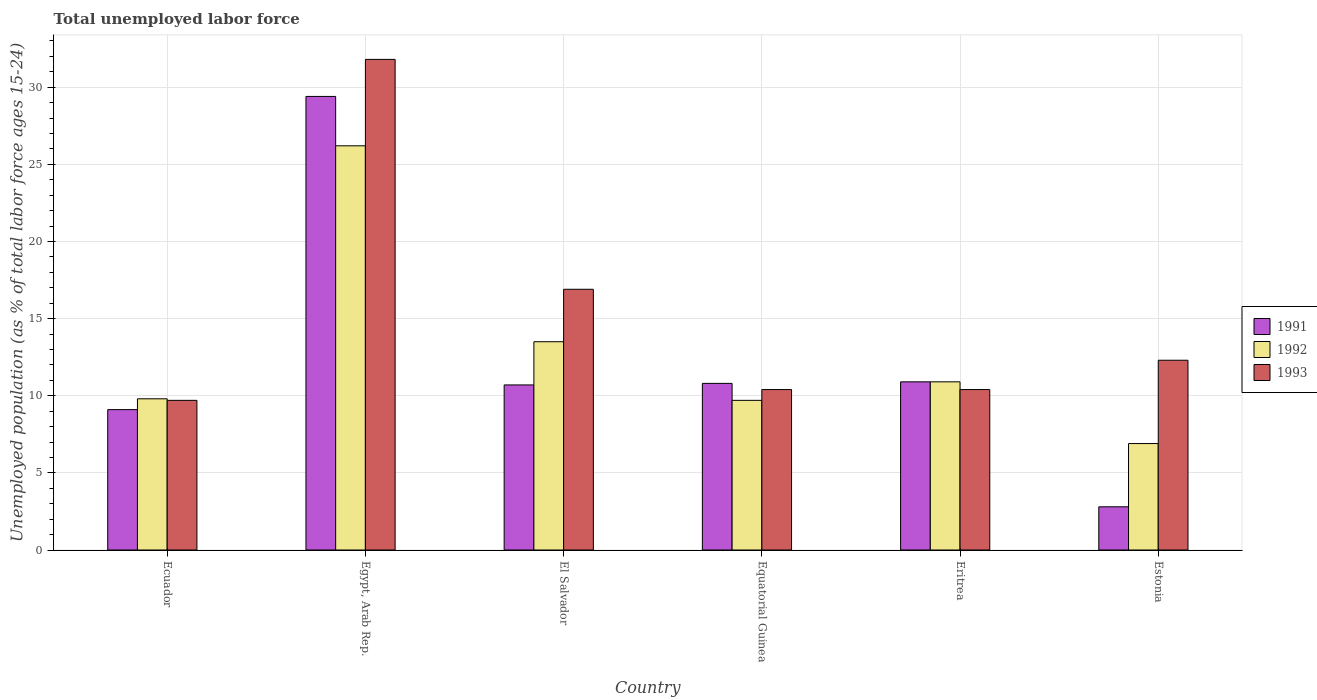How many different coloured bars are there?
Your response must be concise. 3. How many groups of bars are there?
Keep it short and to the point. 6. Are the number of bars per tick equal to the number of legend labels?
Your response must be concise. Yes. Are the number of bars on each tick of the X-axis equal?
Make the answer very short. Yes. How many bars are there on the 4th tick from the left?
Provide a short and direct response. 3. What is the label of the 4th group of bars from the left?
Your answer should be very brief. Equatorial Guinea. In how many cases, is the number of bars for a given country not equal to the number of legend labels?
Give a very brief answer. 0. What is the percentage of unemployed population in in 1992 in Equatorial Guinea?
Keep it short and to the point. 9.7. Across all countries, what is the maximum percentage of unemployed population in in 1992?
Give a very brief answer. 26.2. Across all countries, what is the minimum percentage of unemployed population in in 1991?
Your answer should be compact. 2.8. In which country was the percentage of unemployed population in in 1993 maximum?
Make the answer very short. Egypt, Arab Rep. In which country was the percentage of unemployed population in in 1993 minimum?
Keep it short and to the point. Ecuador. What is the total percentage of unemployed population in in 1991 in the graph?
Make the answer very short. 73.7. What is the difference between the percentage of unemployed population in in 1992 in Equatorial Guinea and that in Estonia?
Provide a succinct answer. 2.8. What is the difference between the percentage of unemployed population in in 1992 in Estonia and the percentage of unemployed population in in 1993 in Ecuador?
Your response must be concise. -2.8. What is the average percentage of unemployed population in in 1991 per country?
Give a very brief answer. 12.28. What is the difference between the percentage of unemployed population in of/in 1992 and percentage of unemployed population in of/in 1991 in Equatorial Guinea?
Offer a very short reply. -1.1. In how many countries, is the percentage of unemployed population in in 1992 greater than 3 %?
Your response must be concise. 6. What is the ratio of the percentage of unemployed population in in 1991 in Equatorial Guinea to that in Estonia?
Your response must be concise. 3.86. Is the percentage of unemployed population in in 1992 in Ecuador less than that in El Salvador?
Ensure brevity in your answer.  Yes. Is the difference between the percentage of unemployed population in in 1992 in Ecuador and Estonia greater than the difference between the percentage of unemployed population in in 1991 in Ecuador and Estonia?
Give a very brief answer. No. What is the difference between the highest and the second highest percentage of unemployed population in in 1993?
Your answer should be compact. 4.6. What is the difference between the highest and the lowest percentage of unemployed population in in 1993?
Give a very brief answer. 22.1. In how many countries, is the percentage of unemployed population in in 1993 greater than the average percentage of unemployed population in in 1993 taken over all countries?
Your answer should be compact. 2. Is the sum of the percentage of unemployed population in in 1992 in Ecuador and Eritrea greater than the maximum percentage of unemployed population in in 1993 across all countries?
Your answer should be compact. No. What does the 2nd bar from the right in Eritrea represents?
Offer a terse response. 1992. Is it the case that in every country, the sum of the percentage of unemployed population in in 1993 and percentage of unemployed population in in 1992 is greater than the percentage of unemployed population in in 1991?
Provide a succinct answer. Yes. Are all the bars in the graph horizontal?
Give a very brief answer. No. How many countries are there in the graph?
Provide a succinct answer. 6. What is the difference between two consecutive major ticks on the Y-axis?
Keep it short and to the point. 5. How many legend labels are there?
Your answer should be compact. 3. How are the legend labels stacked?
Your answer should be compact. Vertical. What is the title of the graph?
Keep it short and to the point. Total unemployed labor force. Does "1996" appear as one of the legend labels in the graph?
Your answer should be very brief. No. What is the label or title of the Y-axis?
Ensure brevity in your answer.  Unemployed population (as % of total labor force ages 15-24). What is the Unemployed population (as % of total labor force ages 15-24) of 1991 in Ecuador?
Offer a terse response. 9.1. What is the Unemployed population (as % of total labor force ages 15-24) in 1992 in Ecuador?
Offer a terse response. 9.8. What is the Unemployed population (as % of total labor force ages 15-24) in 1993 in Ecuador?
Your response must be concise. 9.7. What is the Unemployed population (as % of total labor force ages 15-24) in 1991 in Egypt, Arab Rep.?
Provide a short and direct response. 29.4. What is the Unemployed population (as % of total labor force ages 15-24) in 1992 in Egypt, Arab Rep.?
Provide a short and direct response. 26.2. What is the Unemployed population (as % of total labor force ages 15-24) in 1993 in Egypt, Arab Rep.?
Offer a terse response. 31.8. What is the Unemployed population (as % of total labor force ages 15-24) of 1991 in El Salvador?
Ensure brevity in your answer.  10.7. What is the Unemployed population (as % of total labor force ages 15-24) in 1993 in El Salvador?
Keep it short and to the point. 16.9. What is the Unemployed population (as % of total labor force ages 15-24) of 1991 in Equatorial Guinea?
Provide a short and direct response. 10.8. What is the Unemployed population (as % of total labor force ages 15-24) in 1992 in Equatorial Guinea?
Your response must be concise. 9.7. What is the Unemployed population (as % of total labor force ages 15-24) in 1993 in Equatorial Guinea?
Offer a very short reply. 10.4. What is the Unemployed population (as % of total labor force ages 15-24) of 1991 in Eritrea?
Your response must be concise. 10.9. What is the Unemployed population (as % of total labor force ages 15-24) in 1992 in Eritrea?
Keep it short and to the point. 10.9. What is the Unemployed population (as % of total labor force ages 15-24) of 1993 in Eritrea?
Provide a short and direct response. 10.4. What is the Unemployed population (as % of total labor force ages 15-24) in 1991 in Estonia?
Ensure brevity in your answer.  2.8. What is the Unemployed population (as % of total labor force ages 15-24) in 1992 in Estonia?
Make the answer very short. 6.9. What is the Unemployed population (as % of total labor force ages 15-24) in 1993 in Estonia?
Offer a very short reply. 12.3. Across all countries, what is the maximum Unemployed population (as % of total labor force ages 15-24) of 1991?
Your answer should be very brief. 29.4. Across all countries, what is the maximum Unemployed population (as % of total labor force ages 15-24) in 1992?
Give a very brief answer. 26.2. Across all countries, what is the maximum Unemployed population (as % of total labor force ages 15-24) in 1993?
Keep it short and to the point. 31.8. Across all countries, what is the minimum Unemployed population (as % of total labor force ages 15-24) in 1991?
Offer a very short reply. 2.8. Across all countries, what is the minimum Unemployed population (as % of total labor force ages 15-24) in 1992?
Give a very brief answer. 6.9. Across all countries, what is the minimum Unemployed population (as % of total labor force ages 15-24) of 1993?
Your answer should be compact. 9.7. What is the total Unemployed population (as % of total labor force ages 15-24) in 1991 in the graph?
Make the answer very short. 73.7. What is the total Unemployed population (as % of total labor force ages 15-24) in 1993 in the graph?
Provide a short and direct response. 91.5. What is the difference between the Unemployed population (as % of total labor force ages 15-24) of 1991 in Ecuador and that in Egypt, Arab Rep.?
Your answer should be compact. -20.3. What is the difference between the Unemployed population (as % of total labor force ages 15-24) of 1992 in Ecuador and that in Egypt, Arab Rep.?
Your response must be concise. -16.4. What is the difference between the Unemployed population (as % of total labor force ages 15-24) in 1993 in Ecuador and that in Egypt, Arab Rep.?
Keep it short and to the point. -22.1. What is the difference between the Unemployed population (as % of total labor force ages 15-24) of 1991 in Ecuador and that in El Salvador?
Offer a terse response. -1.6. What is the difference between the Unemployed population (as % of total labor force ages 15-24) of 1993 in Ecuador and that in El Salvador?
Your answer should be compact. -7.2. What is the difference between the Unemployed population (as % of total labor force ages 15-24) of 1991 in Ecuador and that in Equatorial Guinea?
Give a very brief answer. -1.7. What is the difference between the Unemployed population (as % of total labor force ages 15-24) in 1993 in Ecuador and that in Equatorial Guinea?
Keep it short and to the point. -0.7. What is the difference between the Unemployed population (as % of total labor force ages 15-24) in 1992 in Ecuador and that in Eritrea?
Offer a very short reply. -1.1. What is the difference between the Unemployed population (as % of total labor force ages 15-24) of 1993 in Ecuador and that in Eritrea?
Offer a terse response. -0.7. What is the difference between the Unemployed population (as % of total labor force ages 15-24) in 1991 in Ecuador and that in Estonia?
Your response must be concise. 6.3. What is the difference between the Unemployed population (as % of total labor force ages 15-24) in 1992 in Ecuador and that in Estonia?
Your answer should be compact. 2.9. What is the difference between the Unemployed population (as % of total labor force ages 15-24) of 1992 in Egypt, Arab Rep. and that in El Salvador?
Make the answer very short. 12.7. What is the difference between the Unemployed population (as % of total labor force ages 15-24) of 1993 in Egypt, Arab Rep. and that in El Salvador?
Keep it short and to the point. 14.9. What is the difference between the Unemployed population (as % of total labor force ages 15-24) in 1991 in Egypt, Arab Rep. and that in Equatorial Guinea?
Make the answer very short. 18.6. What is the difference between the Unemployed population (as % of total labor force ages 15-24) of 1993 in Egypt, Arab Rep. and that in Equatorial Guinea?
Keep it short and to the point. 21.4. What is the difference between the Unemployed population (as % of total labor force ages 15-24) in 1993 in Egypt, Arab Rep. and that in Eritrea?
Give a very brief answer. 21.4. What is the difference between the Unemployed population (as % of total labor force ages 15-24) of 1991 in Egypt, Arab Rep. and that in Estonia?
Offer a terse response. 26.6. What is the difference between the Unemployed population (as % of total labor force ages 15-24) in 1992 in Egypt, Arab Rep. and that in Estonia?
Provide a short and direct response. 19.3. What is the difference between the Unemployed population (as % of total labor force ages 15-24) of 1991 in El Salvador and that in Equatorial Guinea?
Make the answer very short. -0.1. What is the difference between the Unemployed population (as % of total labor force ages 15-24) of 1992 in El Salvador and that in Eritrea?
Make the answer very short. 2.6. What is the difference between the Unemployed population (as % of total labor force ages 15-24) in 1991 in El Salvador and that in Estonia?
Make the answer very short. 7.9. What is the difference between the Unemployed population (as % of total labor force ages 15-24) of 1992 in Equatorial Guinea and that in Eritrea?
Provide a short and direct response. -1.2. What is the difference between the Unemployed population (as % of total labor force ages 15-24) of 1993 in Equatorial Guinea and that in Eritrea?
Ensure brevity in your answer.  0. What is the difference between the Unemployed population (as % of total labor force ages 15-24) in 1991 in Equatorial Guinea and that in Estonia?
Make the answer very short. 8. What is the difference between the Unemployed population (as % of total labor force ages 15-24) of 1991 in Eritrea and that in Estonia?
Offer a very short reply. 8.1. What is the difference between the Unemployed population (as % of total labor force ages 15-24) of 1993 in Eritrea and that in Estonia?
Your response must be concise. -1.9. What is the difference between the Unemployed population (as % of total labor force ages 15-24) of 1991 in Ecuador and the Unemployed population (as % of total labor force ages 15-24) of 1992 in Egypt, Arab Rep.?
Keep it short and to the point. -17.1. What is the difference between the Unemployed population (as % of total labor force ages 15-24) in 1991 in Ecuador and the Unemployed population (as % of total labor force ages 15-24) in 1993 in Egypt, Arab Rep.?
Keep it short and to the point. -22.7. What is the difference between the Unemployed population (as % of total labor force ages 15-24) in 1992 in Ecuador and the Unemployed population (as % of total labor force ages 15-24) in 1993 in Egypt, Arab Rep.?
Offer a terse response. -22. What is the difference between the Unemployed population (as % of total labor force ages 15-24) in 1991 in Ecuador and the Unemployed population (as % of total labor force ages 15-24) in 1993 in El Salvador?
Make the answer very short. -7.8. What is the difference between the Unemployed population (as % of total labor force ages 15-24) in 1991 in Ecuador and the Unemployed population (as % of total labor force ages 15-24) in 1992 in Equatorial Guinea?
Offer a very short reply. -0.6. What is the difference between the Unemployed population (as % of total labor force ages 15-24) of 1992 in Ecuador and the Unemployed population (as % of total labor force ages 15-24) of 1993 in Equatorial Guinea?
Your response must be concise. -0.6. What is the difference between the Unemployed population (as % of total labor force ages 15-24) in 1991 in Ecuador and the Unemployed population (as % of total labor force ages 15-24) in 1992 in Eritrea?
Keep it short and to the point. -1.8. What is the difference between the Unemployed population (as % of total labor force ages 15-24) of 1992 in Ecuador and the Unemployed population (as % of total labor force ages 15-24) of 1993 in Estonia?
Your answer should be compact. -2.5. What is the difference between the Unemployed population (as % of total labor force ages 15-24) of 1991 in Egypt, Arab Rep. and the Unemployed population (as % of total labor force ages 15-24) of 1992 in El Salvador?
Provide a succinct answer. 15.9. What is the difference between the Unemployed population (as % of total labor force ages 15-24) in 1991 in Egypt, Arab Rep. and the Unemployed population (as % of total labor force ages 15-24) in 1993 in Equatorial Guinea?
Ensure brevity in your answer.  19. What is the difference between the Unemployed population (as % of total labor force ages 15-24) of 1992 in Egypt, Arab Rep. and the Unemployed population (as % of total labor force ages 15-24) of 1993 in Equatorial Guinea?
Your response must be concise. 15.8. What is the difference between the Unemployed population (as % of total labor force ages 15-24) of 1991 in Egypt, Arab Rep. and the Unemployed population (as % of total labor force ages 15-24) of 1992 in Eritrea?
Your answer should be compact. 18.5. What is the difference between the Unemployed population (as % of total labor force ages 15-24) of 1991 in Egypt, Arab Rep. and the Unemployed population (as % of total labor force ages 15-24) of 1992 in Estonia?
Offer a terse response. 22.5. What is the difference between the Unemployed population (as % of total labor force ages 15-24) in 1992 in El Salvador and the Unemployed population (as % of total labor force ages 15-24) in 1993 in Equatorial Guinea?
Provide a succinct answer. 3.1. What is the difference between the Unemployed population (as % of total labor force ages 15-24) of 1991 in El Salvador and the Unemployed population (as % of total labor force ages 15-24) of 1993 in Eritrea?
Your response must be concise. 0.3. What is the difference between the Unemployed population (as % of total labor force ages 15-24) in 1991 in El Salvador and the Unemployed population (as % of total labor force ages 15-24) in 1993 in Estonia?
Offer a very short reply. -1.6. What is the difference between the Unemployed population (as % of total labor force ages 15-24) of 1992 in El Salvador and the Unemployed population (as % of total labor force ages 15-24) of 1993 in Estonia?
Your response must be concise. 1.2. What is the difference between the Unemployed population (as % of total labor force ages 15-24) in 1991 in Equatorial Guinea and the Unemployed population (as % of total labor force ages 15-24) in 1992 in Eritrea?
Ensure brevity in your answer.  -0.1. What is the difference between the Unemployed population (as % of total labor force ages 15-24) of 1991 in Equatorial Guinea and the Unemployed population (as % of total labor force ages 15-24) of 1993 in Eritrea?
Give a very brief answer. 0.4. What is the difference between the Unemployed population (as % of total labor force ages 15-24) of 1992 in Equatorial Guinea and the Unemployed population (as % of total labor force ages 15-24) of 1993 in Eritrea?
Your answer should be very brief. -0.7. What is the difference between the Unemployed population (as % of total labor force ages 15-24) in 1991 in Equatorial Guinea and the Unemployed population (as % of total labor force ages 15-24) in 1992 in Estonia?
Make the answer very short. 3.9. What is the difference between the Unemployed population (as % of total labor force ages 15-24) in 1991 in Equatorial Guinea and the Unemployed population (as % of total labor force ages 15-24) in 1993 in Estonia?
Your answer should be compact. -1.5. What is the difference between the Unemployed population (as % of total labor force ages 15-24) of 1991 in Eritrea and the Unemployed population (as % of total labor force ages 15-24) of 1992 in Estonia?
Provide a short and direct response. 4. What is the difference between the Unemployed population (as % of total labor force ages 15-24) of 1991 in Eritrea and the Unemployed population (as % of total labor force ages 15-24) of 1993 in Estonia?
Provide a short and direct response. -1.4. What is the difference between the Unemployed population (as % of total labor force ages 15-24) in 1992 in Eritrea and the Unemployed population (as % of total labor force ages 15-24) in 1993 in Estonia?
Offer a very short reply. -1.4. What is the average Unemployed population (as % of total labor force ages 15-24) in 1991 per country?
Your answer should be very brief. 12.28. What is the average Unemployed population (as % of total labor force ages 15-24) of 1992 per country?
Provide a succinct answer. 12.83. What is the average Unemployed population (as % of total labor force ages 15-24) of 1993 per country?
Your response must be concise. 15.25. What is the difference between the Unemployed population (as % of total labor force ages 15-24) of 1991 and Unemployed population (as % of total labor force ages 15-24) of 1993 in Ecuador?
Your answer should be very brief. -0.6. What is the difference between the Unemployed population (as % of total labor force ages 15-24) in 1992 and Unemployed population (as % of total labor force ages 15-24) in 1993 in Ecuador?
Offer a terse response. 0.1. What is the difference between the Unemployed population (as % of total labor force ages 15-24) of 1991 and Unemployed population (as % of total labor force ages 15-24) of 1992 in Egypt, Arab Rep.?
Your answer should be compact. 3.2. What is the difference between the Unemployed population (as % of total labor force ages 15-24) of 1992 and Unemployed population (as % of total labor force ages 15-24) of 1993 in Egypt, Arab Rep.?
Make the answer very short. -5.6. What is the difference between the Unemployed population (as % of total labor force ages 15-24) in 1991 and Unemployed population (as % of total labor force ages 15-24) in 1993 in Equatorial Guinea?
Keep it short and to the point. 0.4. What is the difference between the Unemployed population (as % of total labor force ages 15-24) in 1992 and Unemployed population (as % of total labor force ages 15-24) in 1993 in Equatorial Guinea?
Your answer should be very brief. -0.7. What is the difference between the Unemployed population (as % of total labor force ages 15-24) of 1991 and Unemployed population (as % of total labor force ages 15-24) of 1992 in Eritrea?
Your answer should be compact. 0. What is the difference between the Unemployed population (as % of total labor force ages 15-24) in 1991 and Unemployed population (as % of total labor force ages 15-24) in 1993 in Estonia?
Offer a terse response. -9.5. What is the ratio of the Unemployed population (as % of total labor force ages 15-24) of 1991 in Ecuador to that in Egypt, Arab Rep.?
Provide a short and direct response. 0.31. What is the ratio of the Unemployed population (as % of total labor force ages 15-24) in 1992 in Ecuador to that in Egypt, Arab Rep.?
Make the answer very short. 0.37. What is the ratio of the Unemployed population (as % of total labor force ages 15-24) of 1993 in Ecuador to that in Egypt, Arab Rep.?
Your answer should be very brief. 0.3. What is the ratio of the Unemployed population (as % of total labor force ages 15-24) in 1991 in Ecuador to that in El Salvador?
Provide a short and direct response. 0.85. What is the ratio of the Unemployed population (as % of total labor force ages 15-24) of 1992 in Ecuador to that in El Salvador?
Provide a succinct answer. 0.73. What is the ratio of the Unemployed population (as % of total labor force ages 15-24) of 1993 in Ecuador to that in El Salvador?
Give a very brief answer. 0.57. What is the ratio of the Unemployed population (as % of total labor force ages 15-24) of 1991 in Ecuador to that in Equatorial Guinea?
Your answer should be very brief. 0.84. What is the ratio of the Unemployed population (as % of total labor force ages 15-24) of 1992 in Ecuador to that in Equatorial Guinea?
Offer a terse response. 1.01. What is the ratio of the Unemployed population (as % of total labor force ages 15-24) in 1993 in Ecuador to that in Equatorial Guinea?
Offer a very short reply. 0.93. What is the ratio of the Unemployed population (as % of total labor force ages 15-24) of 1991 in Ecuador to that in Eritrea?
Offer a very short reply. 0.83. What is the ratio of the Unemployed population (as % of total labor force ages 15-24) of 1992 in Ecuador to that in Eritrea?
Offer a terse response. 0.9. What is the ratio of the Unemployed population (as % of total labor force ages 15-24) of 1993 in Ecuador to that in Eritrea?
Provide a succinct answer. 0.93. What is the ratio of the Unemployed population (as % of total labor force ages 15-24) in 1992 in Ecuador to that in Estonia?
Ensure brevity in your answer.  1.42. What is the ratio of the Unemployed population (as % of total labor force ages 15-24) of 1993 in Ecuador to that in Estonia?
Your answer should be compact. 0.79. What is the ratio of the Unemployed population (as % of total labor force ages 15-24) of 1991 in Egypt, Arab Rep. to that in El Salvador?
Provide a short and direct response. 2.75. What is the ratio of the Unemployed population (as % of total labor force ages 15-24) of 1992 in Egypt, Arab Rep. to that in El Salvador?
Offer a very short reply. 1.94. What is the ratio of the Unemployed population (as % of total labor force ages 15-24) in 1993 in Egypt, Arab Rep. to that in El Salvador?
Make the answer very short. 1.88. What is the ratio of the Unemployed population (as % of total labor force ages 15-24) in 1991 in Egypt, Arab Rep. to that in Equatorial Guinea?
Make the answer very short. 2.72. What is the ratio of the Unemployed population (as % of total labor force ages 15-24) of 1992 in Egypt, Arab Rep. to that in Equatorial Guinea?
Offer a very short reply. 2.7. What is the ratio of the Unemployed population (as % of total labor force ages 15-24) of 1993 in Egypt, Arab Rep. to that in Equatorial Guinea?
Offer a terse response. 3.06. What is the ratio of the Unemployed population (as % of total labor force ages 15-24) of 1991 in Egypt, Arab Rep. to that in Eritrea?
Your answer should be very brief. 2.7. What is the ratio of the Unemployed population (as % of total labor force ages 15-24) in 1992 in Egypt, Arab Rep. to that in Eritrea?
Make the answer very short. 2.4. What is the ratio of the Unemployed population (as % of total labor force ages 15-24) in 1993 in Egypt, Arab Rep. to that in Eritrea?
Provide a short and direct response. 3.06. What is the ratio of the Unemployed population (as % of total labor force ages 15-24) of 1992 in Egypt, Arab Rep. to that in Estonia?
Keep it short and to the point. 3.8. What is the ratio of the Unemployed population (as % of total labor force ages 15-24) of 1993 in Egypt, Arab Rep. to that in Estonia?
Your response must be concise. 2.59. What is the ratio of the Unemployed population (as % of total labor force ages 15-24) in 1991 in El Salvador to that in Equatorial Guinea?
Offer a very short reply. 0.99. What is the ratio of the Unemployed population (as % of total labor force ages 15-24) in 1992 in El Salvador to that in Equatorial Guinea?
Keep it short and to the point. 1.39. What is the ratio of the Unemployed population (as % of total labor force ages 15-24) in 1993 in El Salvador to that in Equatorial Guinea?
Make the answer very short. 1.62. What is the ratio of the Unemployed population (as % of total labor force ages 15-24) in 1991 in El Salvador to that in Eritrea?
Your answer should be compact. 0.98. What is the ratio of the Unemployed population (as % of total labor force ages 15-24) of 1992 in El Salvador to that in Eritrea?
Offer a very short reply. 1.24. What is the ratio of the Unemployed population (as % of total labor force ages 15-24) in 1993 in El Salvador to that in Eritrea?
Make the answer very short. 1.62. What is the ratio of the Unemployed population (as % of total labor force ages 15-24) in 1991 in El Salvador to that in Estonia?
Ensure brevity in your answer.  3.82. What is the ratio of the Unemployed population (as % of total labor force ages 15-24) of 1992 in El Salvador to that in Estonia?
Make the answer very short. 1.96. What is the ratio of the Unemployed population (as % of total labor force ages 15-24) of 1993 in El Salvador to that in Estonia?
Offer a very short reply. 1.37. What is the ratio of the Unemployed population (as % of total labor force ages 15-24) in 1992 in Equatorial Guinea to that in Eritrea?
Make the answer very short. 0.89. What is the ratio of the Unemployed population (as % of total labor force ages 15-24) in 1991 in Equatorial Guinea to that in Estonia?
Ensure brevity in your answer.  3.86. What is the ratio of the Unemployed population (as % of total labor force ages 15-24) of 1992 in Equatorial Guinea to that in Estonia?
Make the answer very short. 1.41. What is the ratio of the Unemployed population (as % of total labor force ages 15-24) in 1993 in Equatorial Guinea to that in Estonia?
Give a very brief answer. 0.85. What is the ratio of the Unemployed population (as % of total labor force ages 15-24) in 1991 in Eritrea to that in Estonia?
Ensure brevity in your answer.  3.89. What is the ratio of the Unemployed population (as % of total labor force ages 15-24) in 1992 in Eritrea to that in Estonia?
Your answer should be very brief. 1.58. What is the ratio of the Unemployed population (as % of total labor force ages 15-24) of 1993 in Eritrea to that in Estonia?
Your response must be concise. 0.85. What is the difference between the highest and the lowest Unemployed population (as % of total labor force ages 15-24) of 1991?
Your response must be concise. 26.6. What is the difference between the highest and the lowest Unemployed population (as % of total labor force ages 15-24) of 1992?
Ensure brevity in your answer.  19.3. What is the difference between the highest and the lowest Unemployed population (as % of total labor force ages 15-24) of 1993?
Provide a succinct answer. 22.1. 